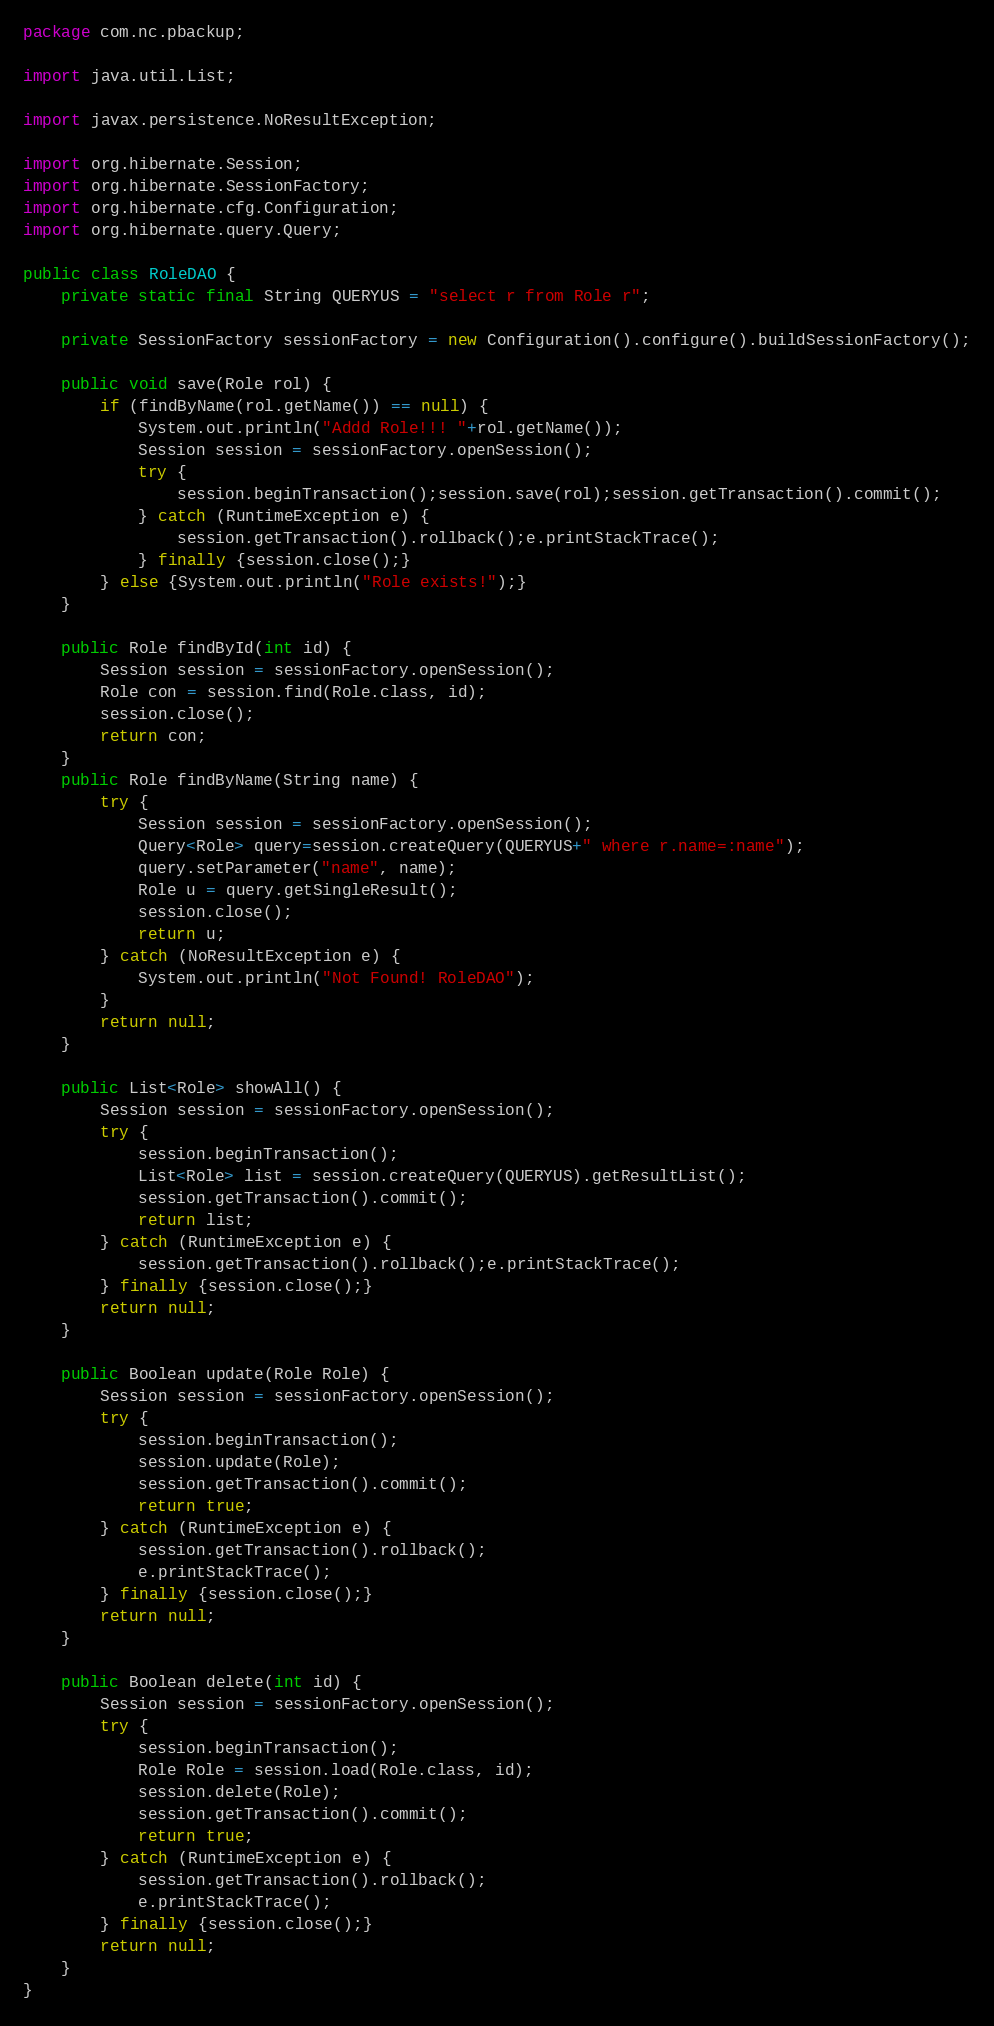Convert code to text. <code><loc_0><loc_0><loc_500><loc_500><_Java_>package com.nc.pbackup;

import java.util.List;

import javax.persistence.NoResultException;

import org.hibernate.Session;
import org.hibernate.SessionFactory;
import org.hibernate.cfg.Configuration;
import org.hibernate.query.Query;

public class RoleDAO {
	private static final String QUERYUS = "select r from Role r";
	
	private SessionFactory sessionFactory = new Configuration().configure().buildSessionFactory();

	public void save(Role rol) {
    	if (findByName(rol.getName()) == null) {
    		System.out.println("Addd Role!!! "+rol.getName());
        	Session session = sessionFactory.openSession();
    		try {
    			session.beginTransaction();session.save(rol);session.getTransaction().commit();
    		} catch (RuntimeException e) {
    			session.getTransaction().rollback();e.printStackTrace();
    		} finally {session.close();}    		
		} else {System.out.println("Role exists!");}
	}

	public Role findById(int id) {
		Session session = sessionFactory.openSession();
		Role con = session.find(Role.class, id);
		session.close();
		return con;
	}
	public Role findByName(String name) {
		try {
			Session session = sessionFactory.openSession();
			Query<Role> query=session.createQuery(QUERYUS+" where r.name=:name");
			query.setParameter("name", name);
			Role u = query.getSingleResult();
			session.close();
			return u;			
		} catch (NoResultException e) {
			System.out.println("Not Found! RoleDAO");
		}
		return null;
	}

	public List<Role> showAll() {
		Session session = sessionFactory.openSession();
		try {
			session.beginTransaction();
			List<Role> list = session.createQuery(QUERYUS).getResultList();
			session.getTransaction().commit();
			return list;
		} catch (RuntimeException e) {
			session.getTransaction().rollback();e.printStackTrace();
		} finally {session.close();}
		return null;
	}

	public Boolean update(Role Role) {
		Session session = sessionFactory.openSession();
		try {
			session.beginTransaction();
			session.update(Role);
			session.getTransaction().commit();
			return true;
		} catch (RuntimeException e) {
			session.getTransaction().rollback();
			e.printStackTrace();
		} finally {session.close();}
		return null;
	}

	public Boolean delete(int id) {
		Session session = sessionFactory.openSession();
		try {
			session.beginTransaction();
			Role Role = session.load(Role.class, id);
			session.delete(Role);
			session.getTransaction().commit();
			return true;
		} catch (RuntimeException e) {
			session.getTransaction().rollback();
			e.printStackTrace();
		} finally {session.close();}
		return null;
	}
}</code> 